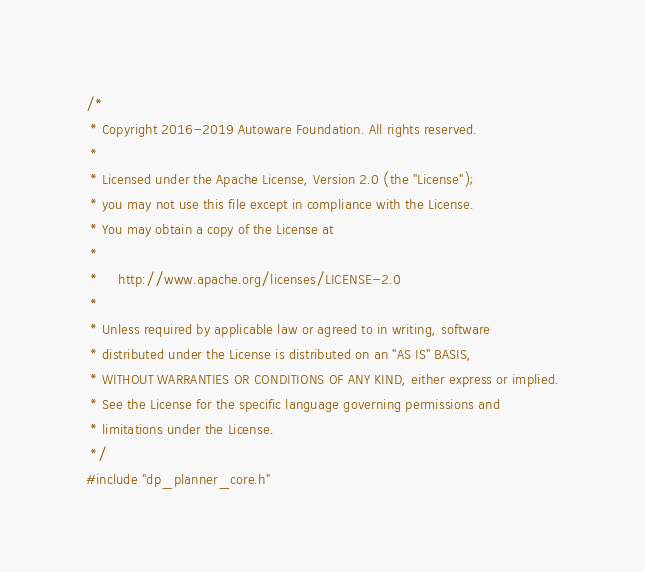<code> <loc_0><loc_0><loc_500><loc_500><_C++_>/*
 * Copyright 2016-2019 Autoware Foundation. All rights reserved.
 *
 * Licensed under the Apache License, Version 2.0 (the "License");
 * you may not use this file except in compliance with the License.
 * You may obtain a copy of the License at
 *
 *     http://www.apache.org/licenses/LICENSE-2.0
 *
 * Unless required by applicable law or agreed to in writing, software
 * distributed under the License is distributed on an "AS IS" BASIS,
 * WITHOUT WARRANTIES OR CONDITIONS OF ANY KIND, either express or implied.
 * See the License for the specific language governing permissions and
 * limitations under the License.
 */
#include "dp_planner_core.h"</code> 